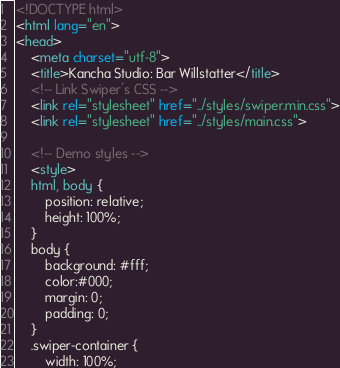Convert code to text. <code><loc_0><loc_0><loc_500><loc_500><_HTML_><!DOCTYPE html>
<html lang="en">
<head>
    <meta charset="utf-8">
    <title>Kancha Studio: Bar Willstatter</title>
    <!-- Link Swiper's CSS -->
    <link rel="stylesheet" href="../styles/swiper.min.css">
    <link rel="stylesheet" href="../styles/main.css">

    <!-- Demo styles -->
    <style>
    html, body {
        position: relative;
        height: 100%;
    }
    body {
        background: #fff;
        color:#000;
        margin: 0;
        padding: 0;
    }
    .swiper-container {
        width: 100%;</code> 